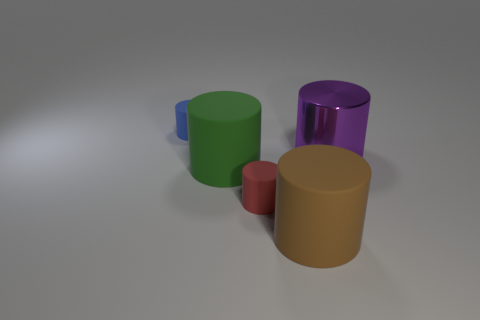Is the big brown thing made of the same material as the big cylinder that is to the right of the brown cylinder?
Make the answer very short. No. Do the blue rubber object and the shiny thing have the same shape?
Make the answer very short. Yes. There is a big purple object that is the same shape as the large green object; what is its material?
Make the answer very short. Metal. There is a large cylinder that is behind the tiny red matte object and on the right side of the red object; what color is it?
Provide a succinct answer. Purple. The big metal object is what color?
Provide a short and direct response. Purple. Are there any big green objects of the same shape as the blue matte thing?
Your answer should be very brief. Yes. What size is the brown object in front of the green cylinder?
Give a very brief answer. Large. There is a purple object that is the same size as the green matte cylinder; what is it made of?
Provide a succinct answer. Metal. Is the number of big purple shiny objects greater than the number of tiny cylinders?
Your response must be concise. No. There is a object that is behind the large shiny cylinder that is behind the brown cylinder; what is its size?
Provide a succinct answer. Small. 